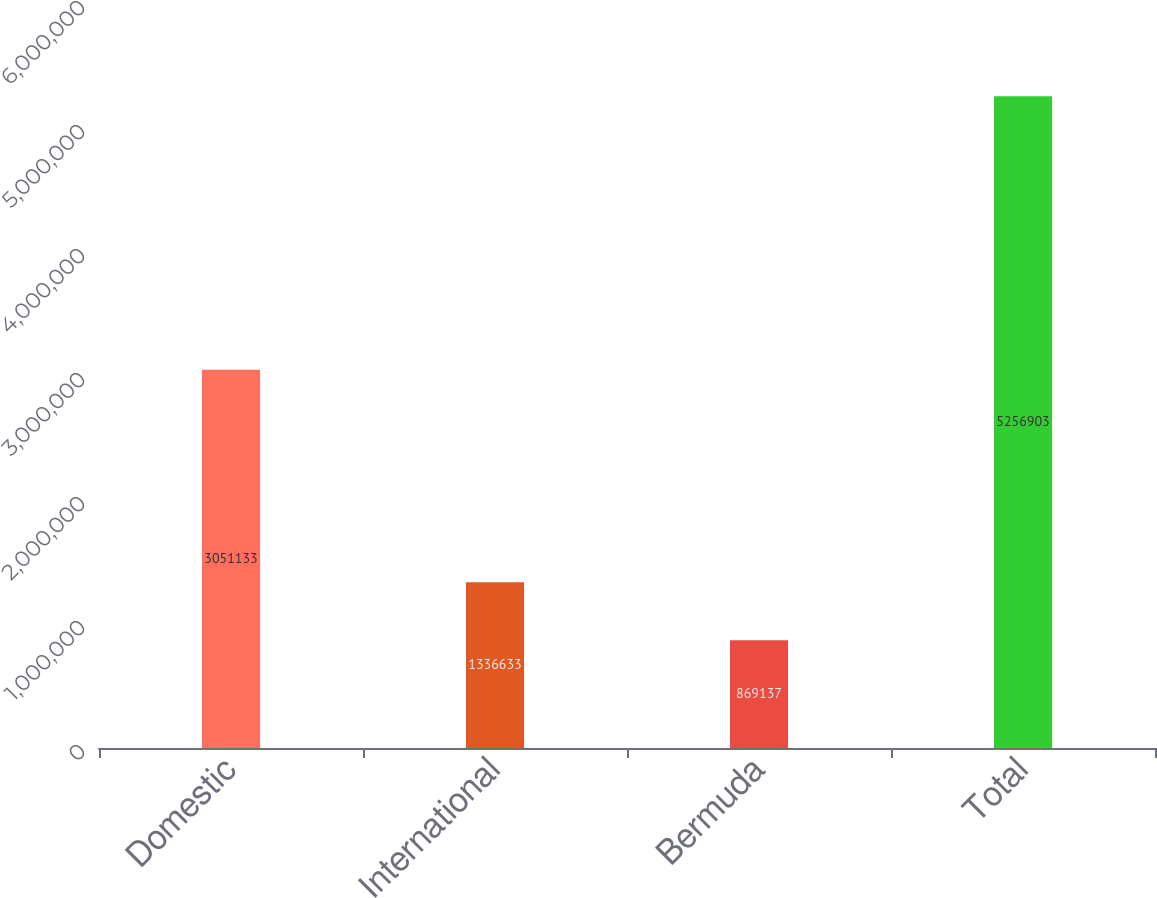<chart> <loc_0><loc_0><loc_500><loc_500><bar_chart><fcel>Domestic<fcel>International<fcel>Bermuda<fcel>Total<nl><fcel>3.05113e+06<fcel>1.33663e+06<fcel>869137<fcel>5.2569e+06<nl></chart> 